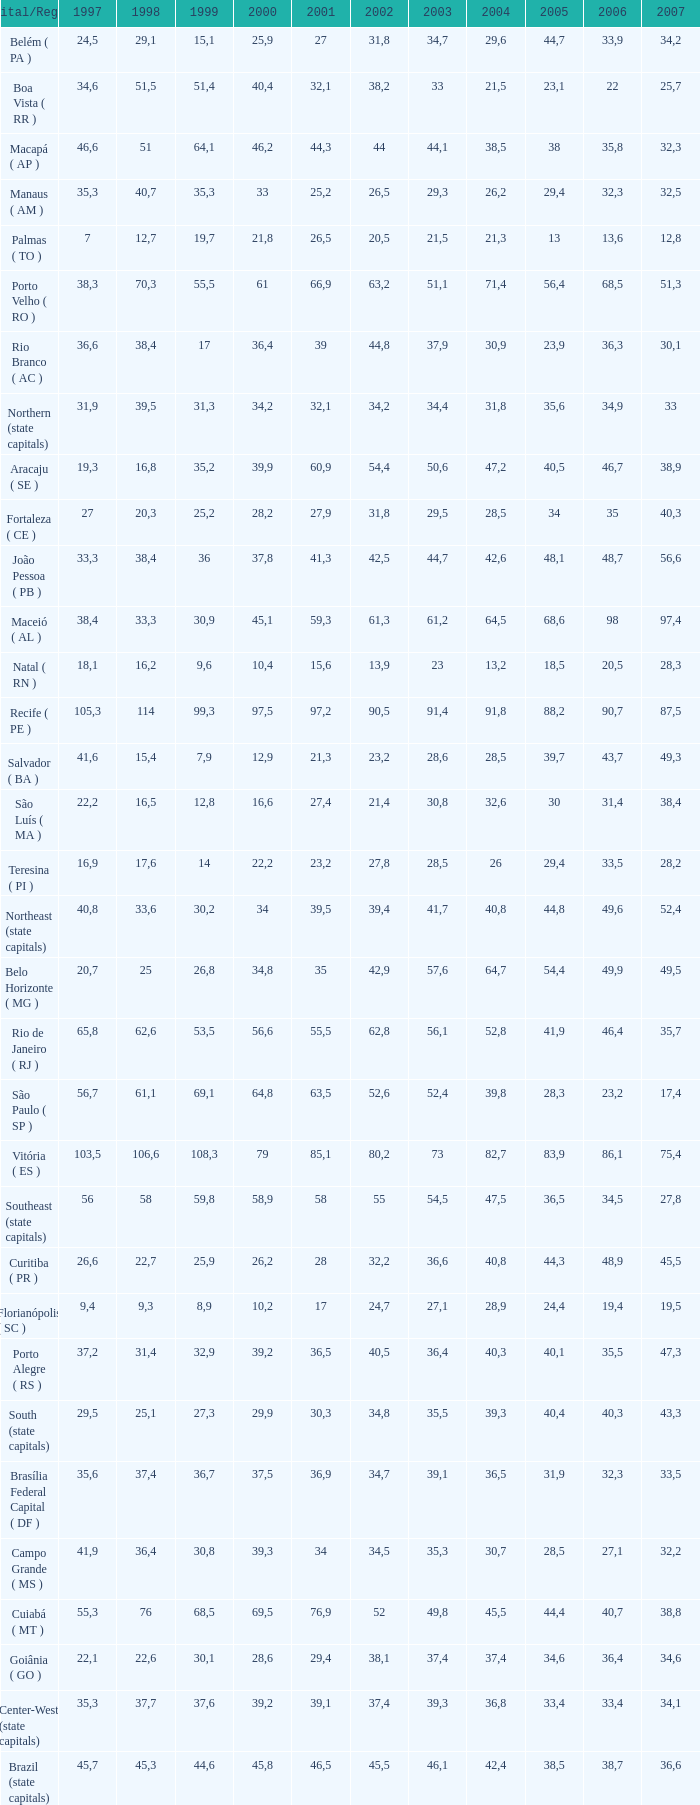Parse the table in full. {'header': ['Capital/Region', '1997', '1998', '1999', '2000', '2001', '2002', '2003', '2004', '2005', '2006', '2007'], 'rows': [['Belém ( PA )', '24,5', '29,1', '15,1', '25,9', '27', '31,8', '34,7', '29,6', '44,7', '33,9', '34,2'], ['Boa Vista ( RR )', '34,6', '51,5', '51,4', '40,4', '32,1', '38,2', '33', '21,5', '23,1', '22', '25,7'], ['Macapá ( AP )', '46,6', '51', '64,1', '46,2', '44,3', '44', '44,1', '38,5', '38', '35,8', '32,3'], ['Manaus ( AM )', '35,3', '40,7', '35,3', '33', '25,2', '26,5', '29,3', '26,2', '29,4', '32,3', '32,5'], ['Palmas ( TO )', '7', '12,7', '19,7', '21,8', '26,5', '20,5', '21,5', '21,3', '13', '13,6', '12,8'], ['Porto Velho ( RO )', '38,3', '70,3', '55,5', '61', '66,9', '63,2', '51,1', '71,4', '56,4', '68,5', '51,3'], ['Rio Branco ( AC )', '36,6', '38,4', '17', '36,4', '39', '44,8', '37,9', '30,9', '23,9', '36,3', '30,1'], ['Northern (state capitals)', '31,9', '39,5', '31,3', '34,2', '32,1', '34,2', '34,4', '31,8', '35,6', '34,9', '33'], ['Aracaju ( SE )', '19,3', '16,8', '35,2', '39,9', '60,9', '54,4', '50,6', '47,2', '40,5', '46,7', '38,9'], ['Fortaleza ( CE )', '27', '20,3', '25,2', '28,2', '27,9', '31,8', '29,5', '28,5', '34', '35', '40,3'], ['João Pessoa ( PB )', '33,3', '38,4', '36', '37,8', '41,3', '42,5', '44,7', '42,6', '48,1', '48,7', '56,6'], ['Maceió ( AL )', '38,4', '33,3', '30,9', '45,1', '59,3', '61,3', '61,2', '64,5', '68,6', '98', '97,4'], ['Natal ( RN )', '18,1', '16,2', '9,6', '10,4', '15,6', '13,9', '23', '13,2', '18,5', '20,5', '28,3'], ['Recife ( PE )', '105,3', '114', '99,3', '97,5', '97,2', '90,5', '91,4', '91,8', '88,2', '90,7', '87,5'], ['Salvador ( BA )', '41,6', '15,4', '7,9', '12,9', '21,3', '23,2', '28,6', '28,5', '39,7', '43,7', '49,3'], ['São Luís ( MA )', '22,2', '16,5', '12,8', '16,6', '27,4', '21,4', '30,8', '32,6', '30', '31,4', '38,4'], ['Teresina ( PI )', '16,9', '17,6', '14', '22,2', '23,2', '27,8', '28,5', '26', '29,4', '33,5', '28,2'], ['Northeast (state capitals)', '40,8', '33,6', '30,2', '34', '39,5', '39,4', '41,7', '40,8', '44,8', '49,6', '52,4'], ['Belo Horizonte ( MG )', '20,7', '25', '26,8', '34,8', '35', '42,9', '57,6', '64,7', '54,4', '49,9', '49,5'], ['Rio de Janeiro ( RJ )', '65,8', '62,6', '53,5', '56,6', '55,5', '62,8', '56,1', '52,8', '41,9', '46,4', '35,7'], ['São Paulo ( SP )', '56,7', '61,1', '69,1', '64,8', '63,5', '52,6', '52,4', '39,8', '28,3', '23,2', '17,4'], ['Vitória ( ES )', '103,5', '106,6', '108,3', '79', '85,1', '80,2', '73', '82,7', '83,9', '86,1', '75,4'], ['Southeast (state capitals)', '56', '58', '59,8', '58,9', '58', '55', '54,5', '47,5', '36,5', '34,5', '27,8'], ['Curitiba ( PR )', '26,6', '22,7', '25,9', '26,2', '28', '32,2', '36,6', '40,8', '44,3', '48,9', '45,5'], ['Florianópolis ( SC )', '9,4', '9,3', '8,9', '10,2', '17', '24,7', '27,1', '28,9', '24,4', '19,4', '19,5'], ['Porto Alegre ( RS )', '37,2', '31,4', '32,9', '39,2', '36,5', '40,5', '36,4', '40,3', '40,1', '35,5', '47,3'], ['South (state capitals)', '29,5', '25,1', '27,3', '29,9', '30,3', '34,8', '35,5', '39,3', '40,4', '40,3', '43,3'], ['Brasília Federal Capital ( DF )', '35,6', '37,4', '36,7', '37,5', '36,9', '34,7', '39,1', '36,5', '31,9', '32,3', '33,5'], ['Campo Grande ( MS )', '41,9', '36,4', '30,8', '39,3', '34', '34,5', '35,3', '30,7', '28,5', '27,1', '32,2'], ['Cuiabá ( MT )', '55,3', '76', '68,5', '69,5', '76,9', '52', '49,8', '45,5', '44,4', '40,7', '38,8'], ['Goiânia ( GO )', '22,1', '22,6', '30,1', '28,6', '29,4', '38,1', '37,4', '37,4', '34,6', '36,4', '34,6'], ['Center-West (state capitals)', '35,3', '37,7', '37,6', '39,2', '39,1', '37,4', '39,3', '36,8', '33,4', '33,4', '34,1'], ['Brazil (state capitals)', '45,7', '45,3', '44,6', '45,8', '46,5', '45,5', '46,1', '42,4', '38,5', '38,7', '36,6']]} How many 2007's possess a 2003 below 36,4, 27,9 as a 2001, and a 1999 under 25,2? None. 